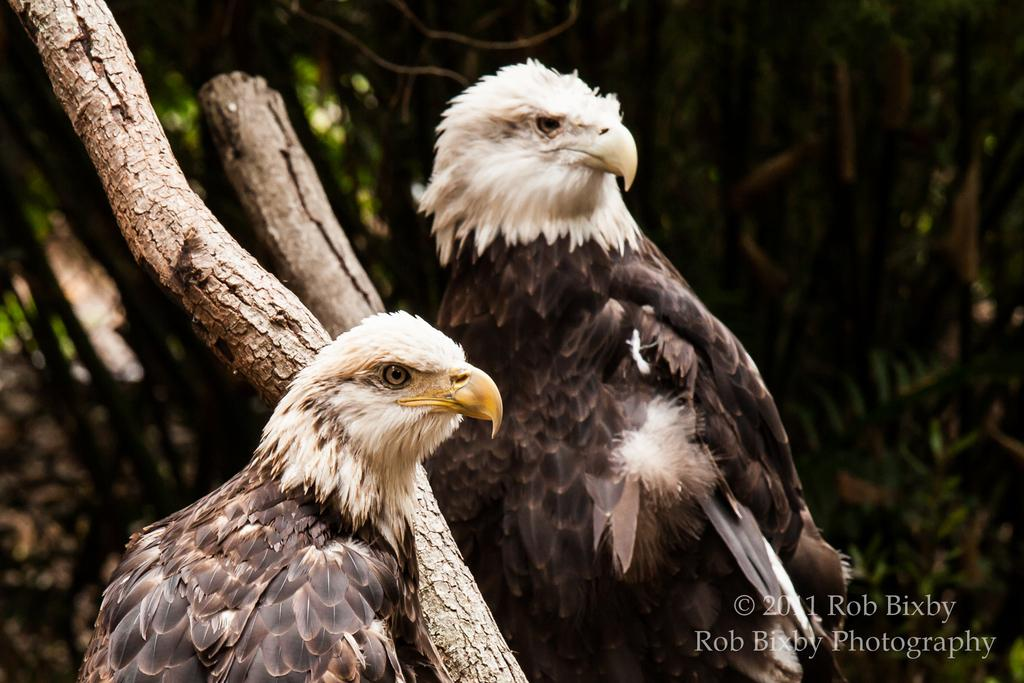What animals are present in the image? There are two eagles in the image. Can you describe the coloring of the eagles? The eagles have brown, black, cream, and white coloring. What object can be seen in the image besides the eagles? There is a wooden log in the image. What is the color of the wooden log? The wooden log is brown in color. What can be seen in the background of the image? There are trees in the background of the image. What type of tiger can be seen roaring in the image? There is no tiger present in the image; it features two eagles and a wooden log. What is the cause of the eagle's throat pain in the image? There is no indication of any throat pain or discomfort for the eagles in the image. 